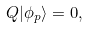Convert formula to latex. <formula><loc_0><loc_0><loc_500><loc_500>Q | \phi _ { p } \rangle = 0 ,</formula> 